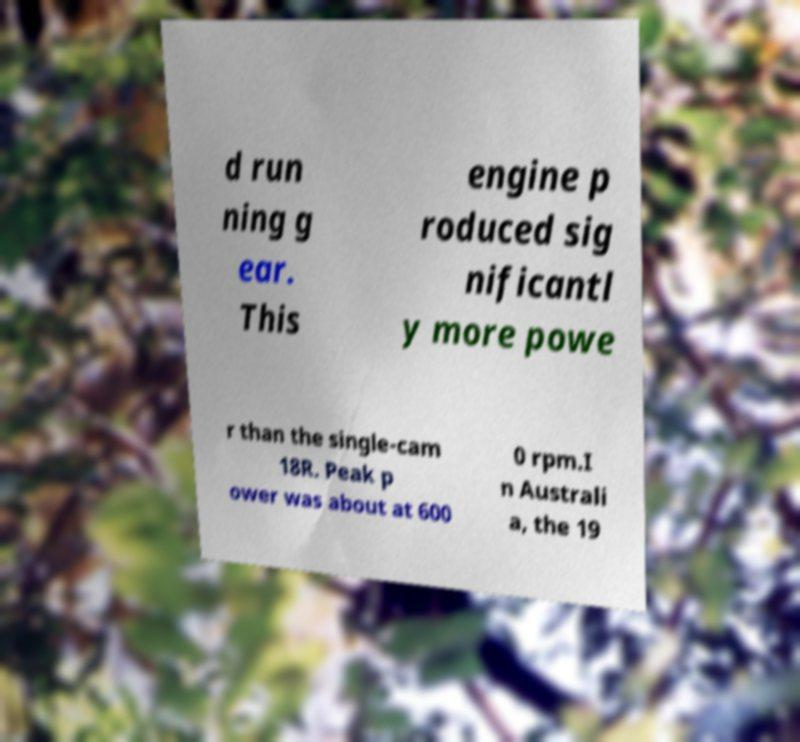Please identify and transcribe the text found in this image. d run ning g ear. This engine p roduced sig nificantl y more powe r than the single-cam 18R. Peak p ower was about at 600 0 rpm.I n Australi a, the 19 